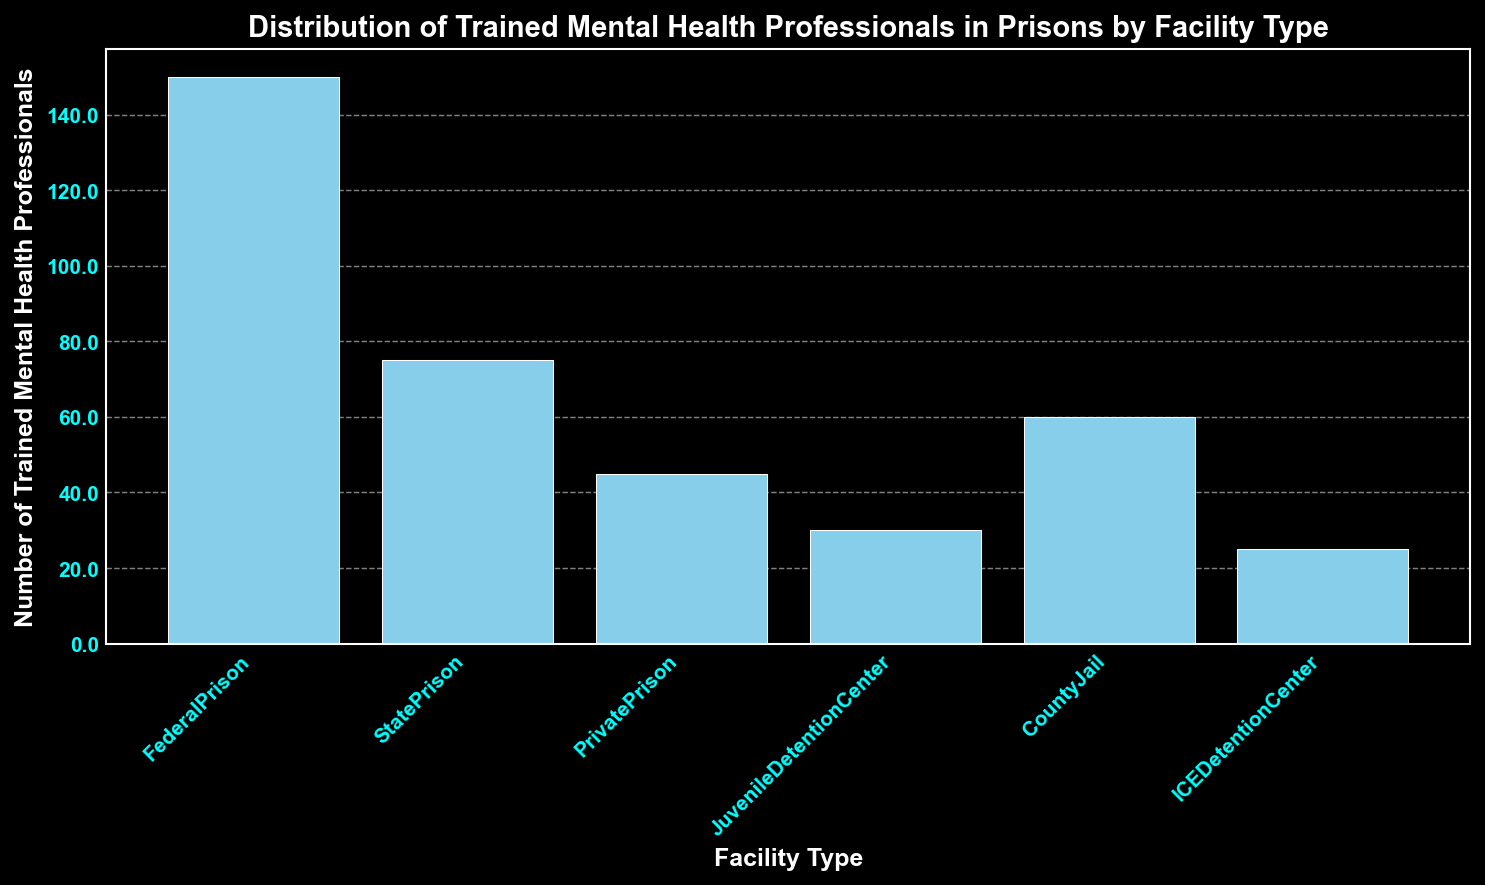Which facility type has the highest number of trained mental health professionals? By observing the heights of the bars, the tallest bar represents FederalPrison which has the highest number of trained mental health professionals.
Answer: FederalPrison What is the difference in the number of trained mental health professionals between FederalPrison and StatePrison? FederalPrison has 150 professionals and StatePrison has 75 professionals. The difference is calculated by subtracting the number for StatePrison from that for FederalPrison: 150 - 75.
Answer: 75 How many mental health professionals are there in total across all facility types? To get the total, sum up the numbers for all facility types: 150 (FederalPrison) + 75 (StatePrison) + 45 (PrivatePrison) + 30 (JuvenileDetentionCenter) + 60 (CountyJail) + 25 (ICEDetentionCenter). This equals 385.
Answer: 385 Is the number of trained mental health professionals in CountyJail greater than in PrivatePrison? Compare the heights of the bars for CountyJail (60) and PrivatePrison (45). Since 60 is greater than 45, CountyJail has more professionals than PrivatePrison.
Answer: Yes What is the average number of trained mental health professionals per facility type? The total number of professionals is 385 and there are 6 facility types. The average is found by dividing the total by the number of facility types: 385 / 6.
Answer: 64.17 Which facility type has the least number of trained mental health professionals? By observing the heights of the bars, the shortest bar represents ICEDetentionCenter, which has the least number of trained mental health professionals.
Answer: ICEDetentionCenter What is the combined total of trained mental health professionals in StatePrison and CountyJail? StatePrison has 75 professionals, and CountyJail has 60 professionals. The combined total is calculated by adding these two numbers: 75 + 60.
Answer: 135 Are there more trained mental health professionals in StatePrison compared to FederalPrison and CountyJail combined? FederalPrison has 150 professionals, and CountyJail has 60 professionals, giving a combined total of 210. Compare this with StatePrison's number, 75. Since 75 is less than 210, the answer is no.
Answer: No How does the bar's height for JuvenileDetentionCenter compare to ICEDetentionCenter? By comparing the heights of the bars, JuvenileDetentionCenter (30) is taller than ICEDetentionCenter (25).
Answer: Taller 